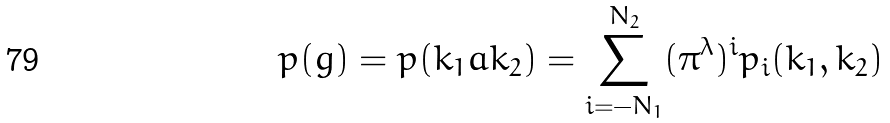<formula> <loc_0><loc_0><loc_500><loc_500>p ( g ) = p ( k _ { 1 } a k _ { 2 } ) = \sum _ { i = - N _ { 1 } } ^ { N _ { 2 } } ( \pi ^ { \lambda } ) ^ { i } p _ { i } ( k _ { 1 } , k _ { 2 } )</formula> 